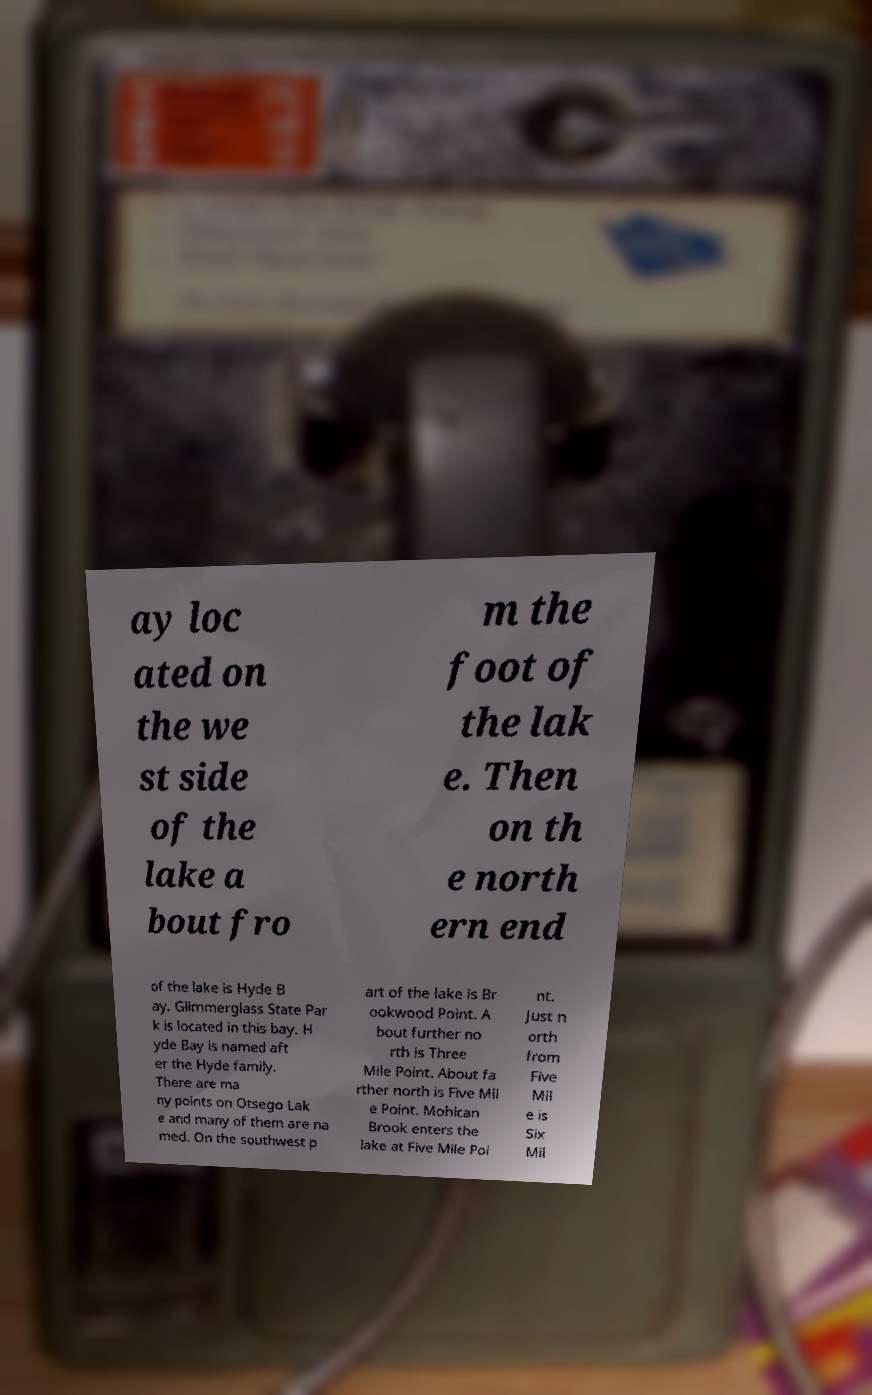Can you read and provide the text displayed in the image?This photo seems to have some interesting text. Can you extract and type it out for me? ay loc ated on the we st side of the lake a bout fro m the foot of the lak e. Then on th e north ern end of the lake is Hyde B ay. Glimmerglass State Par k is located in this bay. H yde Bay is named aft er the Hyde family. There are ma ny points on Otsego Lak e and many of them are na med. On the southwest p art of the lake is Br ookwood Point. A bout further no rth is Three Mile Point. About fa rther north is Five Mil e Point. Mohican Brook enters the lake at Five Mile Poi nt. Just n orth from Five Mil e is Six Mil 